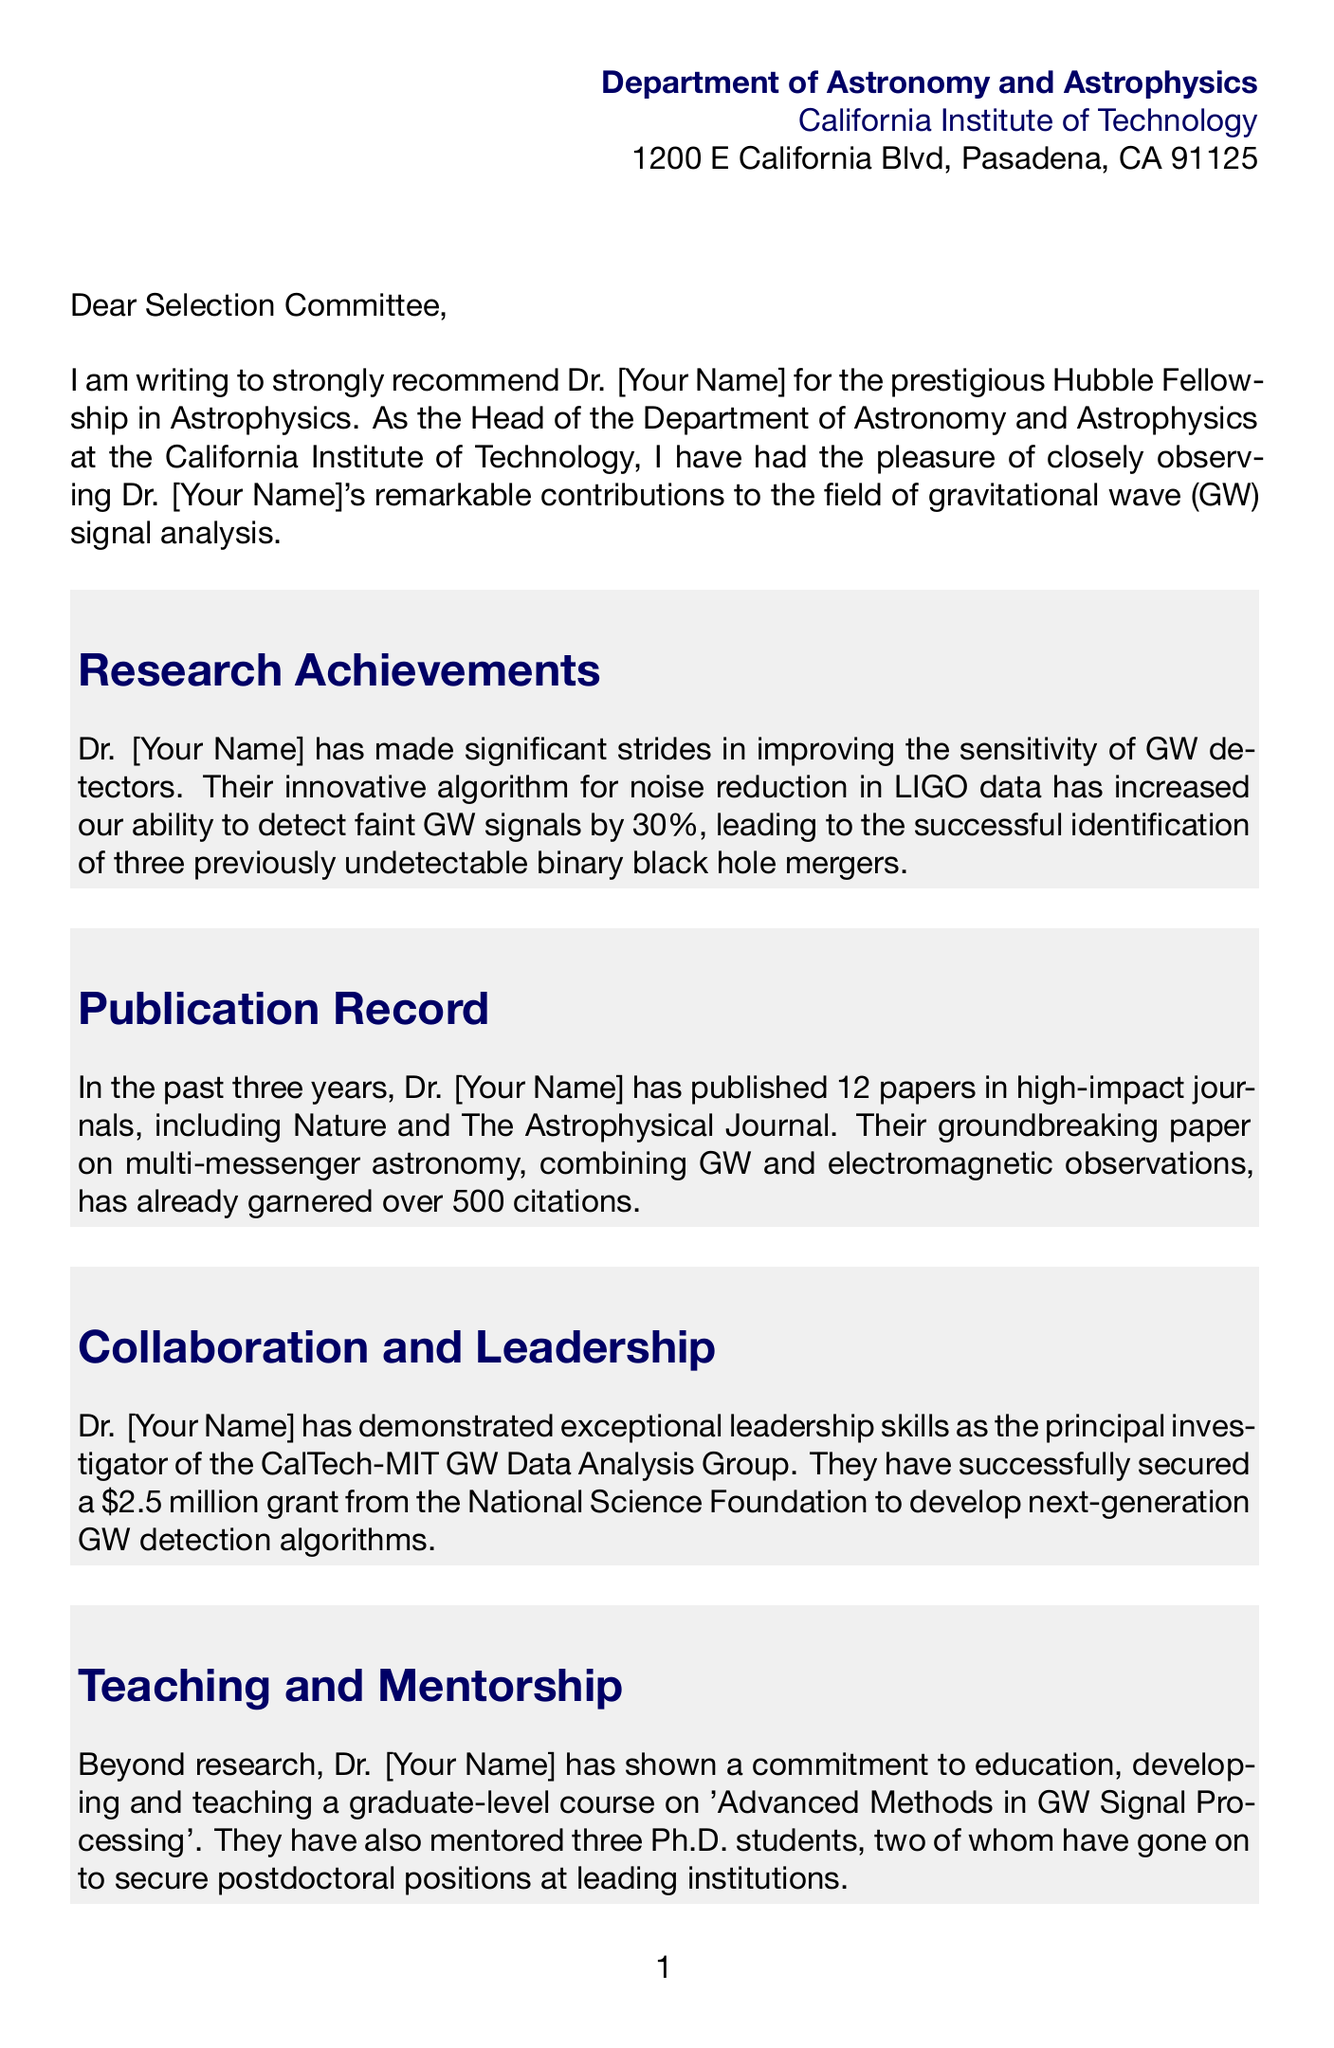What is the name of the fellowship? The document mentions the fellowship as the prestigious Hubble Fellowship in Astrophysics.
Answer: Hubble Fellowship Who is recommending Dr. [Your Name]? The letter is written by Dr. Fiona Dowson, the Head of the Department of Astronomy and Astrophysics.
Answer: Dr. Fiona Dowson How many papers has Dr. [Your Name] published in the last three years? The document states that Dr. [Your Name] has published 12 papers in high-impact journals.
Answer: 12 papers What is the grant amount secured by Dr. [Your Name] for developing GW detection algorithms? The letter mentions a secured grant of 2.5 million dollars from the National Science Foundation.
Answer: 2.5 million dollars What significant contribution did Dr. [Your Name] make to LIGO? The document highlights that Dr. [Your Name] developed an algorithm that improved LIGO's sensitivity by 30%.
Answer: 30% What course did Dr. [Your Name] teach? The letter mentions Dr. [Your Name] developed and taught a graduate-level course on 'Advanced Methods in GW Signal Processing'.
Answer: Advanced Methods in GW Signal Processing How many Ph.D. students has Dr. [Your Name] mentored? The document indicates that Dr. [Your Name] has mentored three Ph.D. students.
Answer: Three What is the main focus of Dr. [Your Name]'s research achievements? The document emphasizes improving the sensitivity of gravitational wave detectors through noises reduction algorithms.
Answer: Improving sensitivity of gravitational wave detectors What year was the AAS Bruno Rossi Prize awarded? The document notes that the AAS Bruno Rossi Prize was awarded in 2022.
Answer: 2022 